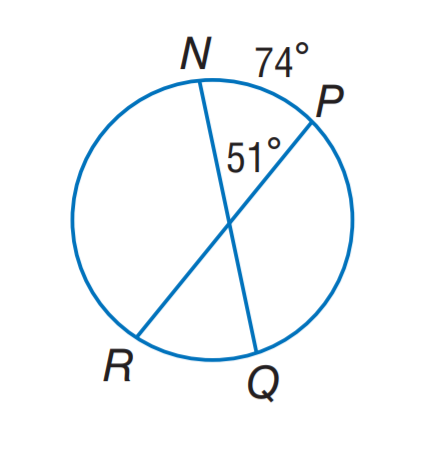Answer the mathemtical geometry problem and directly provide the correct option letter.
Question: Find m \widehat R Q.
Choices: A: 14 B: 28 C: 37 D: 51 B 